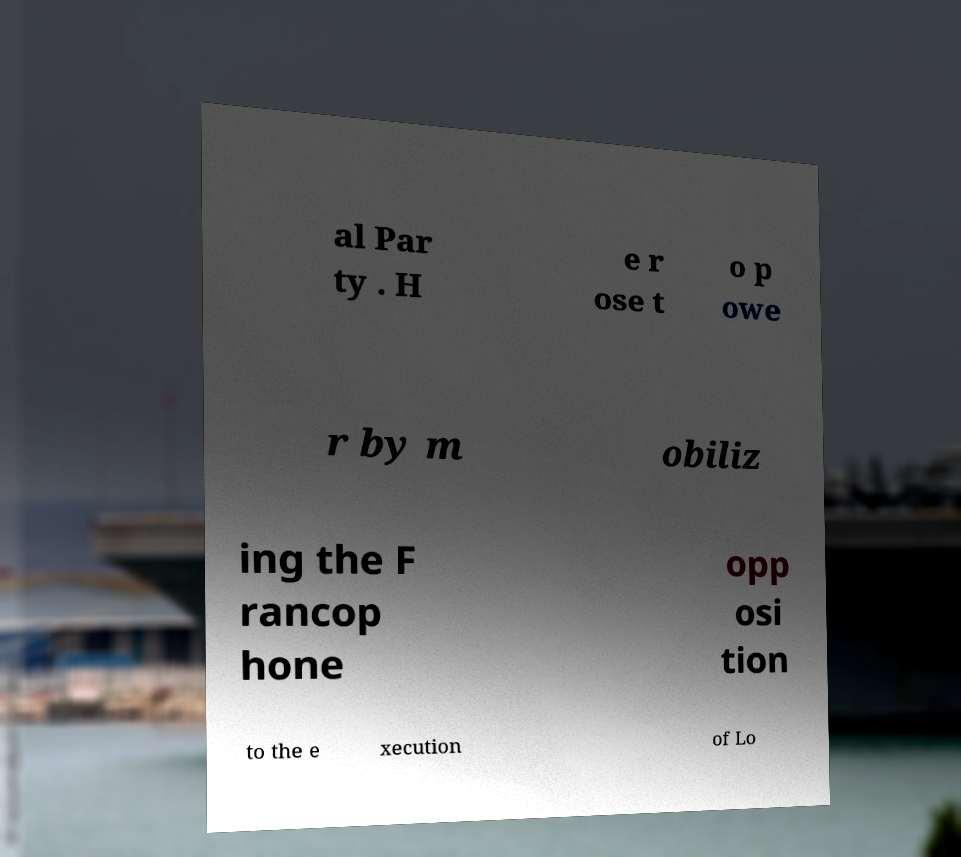Can you read and provide the text displayed in the image?This photo seems to have some interesting text. Can you extract and type it out for me? al Par ty . H e r ose t o p owe r by m obiliz ing the F rancop hone opp osi tion to the e xecution of Lo 